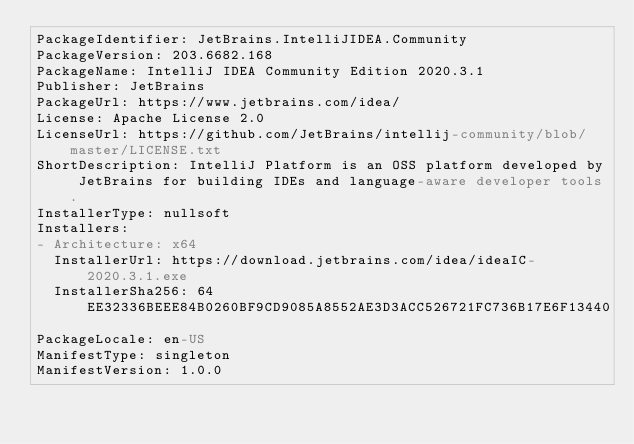Convert code to text. <code><loc_0><loc_0><loc_500><loc_500><_YAML_>PackageIdentifier: JetBrains.IntelliJIDEA.Community
PackageVersion: 203.6682.168
PackageName: IntelliJ IDEA Community Edition 2020.3.1
Publisher: JetBrains
PackageUrl: https://www.jetbrains.com/idea/
License: Apache License 2.0
LicenseUrl: https://github.com/JetBrains/intellij-community/blob/master/LICENSE.txt
ShortDescription: IntelliJ Platform is an OSS platform developed by JetBrains for building IDEs and language-aware developer tools.
InstallerType: nullsoft
Installers:
- Architecture: x64
  InstallerUrl: https://download.jetbrains.com/idea/ideaIC-2020.3.1.exe
  InstallerSha256: 64EE32336BEEE84B0260BF9CD9085A8552AE3D3ACC526721FC736B17E6F13440
PackageLocale: en-US
ManifestType: singleton
ManifestVersion: 1.0.0
</code> 